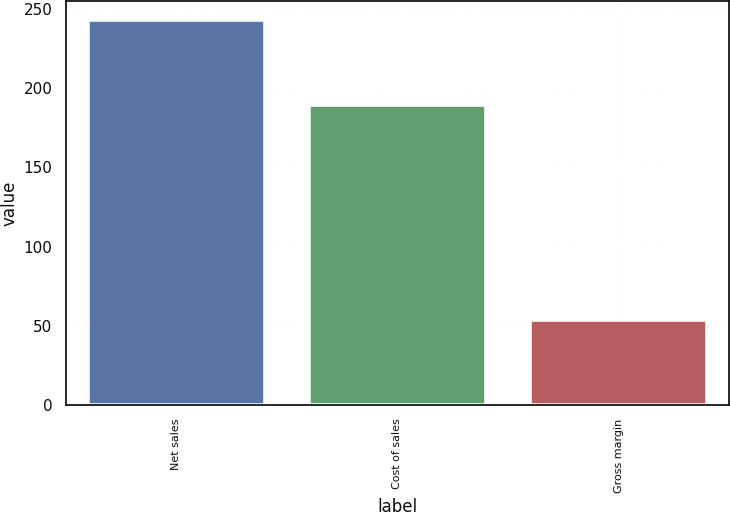<chart> <loc_0><loc_0><loc_500><loc_500><bar_chart><fcel>Net sales<fcel>Cost of sales<fcel>Gross margin<nl><fcel>242.7<fcel>189.1<fcel>53.6<nl></chart> 